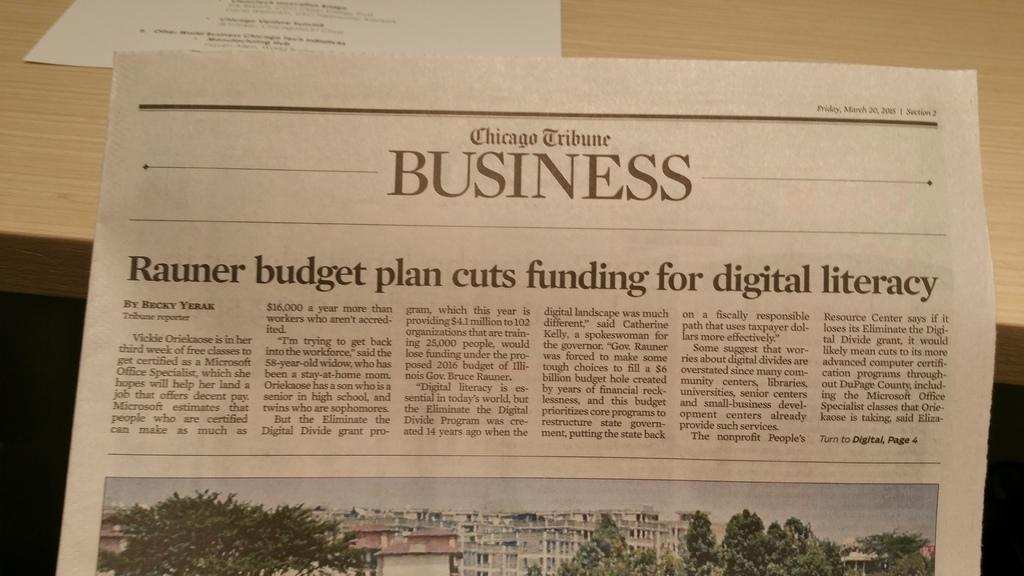Provide a one-sentence caption for the provided image. An image of a business page from the Chicago Tribune. 